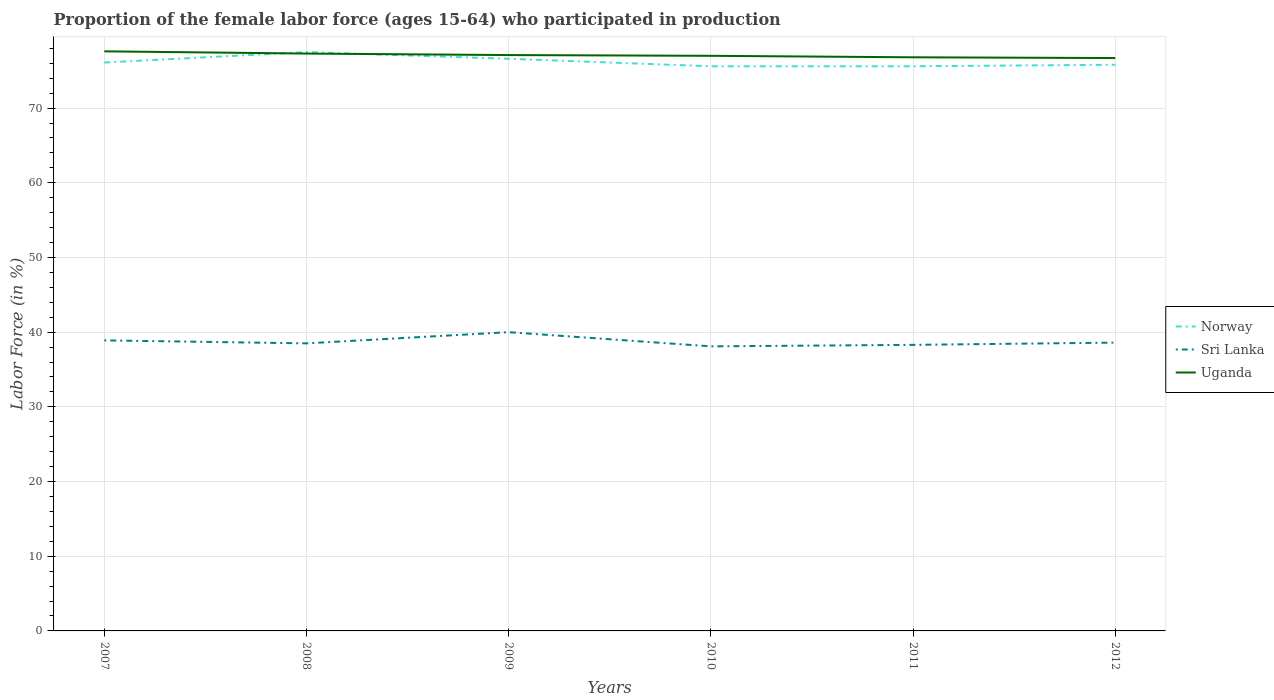Across all years, what is the maximum proportion of the female labor force who participated in production in Uganda?
Offer a terse response. 76.7. What is the total proportion of the female labor force who participated in production in Uganda in the graph?
Offer a very short reply. 0.6. What is the difference between the highest and the second highest proportion of the female labor force who participated in production in Uganda?
Offer a terse response. 0.9. Are the values on the major ticks of Y-axis written in scientific E-notation?
Your response must be concise. No. Does the graph contain grids?
Ensure brevity in your answer.  Yes. Where does the legend appear in the graph?
Your answer should be compact. Center right. How many legend labels are there?
Provide a succinct answer. 3. How are the legend labels stacked?
Provide a succinct answer. Vertical. What is the title of the graph?
Your answer should be compact. Proportion of the female labor force (ages 15-64) who participated in production. Does "Italy" appear as one of the legend labels in the graph?
Your response must be concise. No. What is the Labor Force (in %) of Norway in 2007?
Make the answer very short. 76.1. What is the Labor Force (in %) of Sri Lanka in 2007?
Offer a very short reply. 38.9. What is the Labor Force (in %) in Uganda in 2007?
Keep it short and to the point. 77.6. What is the Labor Force (in %) of Norway in 2008?
Make the answer very short. 77.5. What is the Labor Force (in %) of Sri Lanka in 2008?
Provide a short and direct response. 38.5. What is the Labor Force (in %) in Uganda in 2008?
Your response must be concise. 77.3. What is the Labor Force (in %) of Norway in 2009?
Your response must be concise. 76.6. What is the Labor Force (in %) of Uganda in 2009?
Your answer should be very brief. 77.1. What is the Labor Force (in %) in Norway in 2010?
Offer a very short reply. 75.6. What is the Labor Force (in %) of Sri Lanka in 2010?
Offer a very short reply. 38.1. What is the Labor Force (in %) in Norway in 2011?
Ensure brevity in your answer.  75.6. What is the Labor Force (in %) in Sri Lanka in 2011?
Your answer should be compact. 38.3. What is the Labor Force (in %) of Uganda in 2011?
Offer a terse response. 76.8. What is the Labor Force (in %) of Norway in 2012?
Ensure brevity in your answer.  75.8. What is the Labor Force (in %) of Sri Lanka in 2012?
Your answer should be compact. 38.6. What is the Labor Force (in %) in Uganda in 2012?
Offer a very short reply. 76.7. Across all years, what is the maximum Labor Force (in %) of Norway?
Keep it short and to the point. 77.5. Across all years, what is the maximum Labor Force (in %) in Sri Lanka?
Provide a succinct answer. 40. Across all years, what is the maximum Labor Force (in %) in Uganda?
Your answer should be compact. 77.6. Across all years, what is the minimum Labor Force (in %) of Norway?
Provide a short and direct response. 75.6. Across all years, what is the minimum Labor Force (in %) of Sri Lanka?
Offer a very short reply. 38.1. Across all years, what is the minimum Labor Force (in %) in Uganda?
Keep it short and to the point. 76.7. What is the total Labor Force (in %) of Norway in the graph?
Give a very brief answer. 457.2. What is the total Labor Force (in %) in Sri Lanka in the graph?
Keep it short and to the point. 232.4. What is the total Labor Force (in %) in Uganda in the graph?
Provide a short and direct response. 462.5. What is the difference between the Labor Force (in %) of Norway in 2007 and that in 2008?
Offer a terse response. -1.4. What is the difference between the Labor Force (in %) of Uganda in 2007 and that in 2008?
Your response must be concise. 0.3. What is the difference between the Labor Force (in %) in Norway in 2007 and that in 2010?
Keep it short and to the point. 0.5. What is the difference between the Labor Force (in %) of Norway in 2007 and that in 2011?
Your answer should be compact. 0.5. What is the difference between the Labor Force (in %) in Sri Lanka in 2007 and that in 2011?
Offer a terse response. 0.6. What is the difference between the Labor Force (in %) in Sri Lanka in 2007 and that in 2012?
Make the answer very short. 0.3. What is the difference between the Labor Force (in %) of Uganda in 2007 and that in 2012?
Offer a very short reply. 0.9. What is the difference between the Labor Force (in %) in Uganda in 2008 and that in 2009?
Offer a terse response. 0.2. What is the difference between the Labor Force (in %) in Norway in 2008 and that in 2010?
Offer a very short reply. 1.9. What is the difference between the Labor Force (in %) in Sri Lanka in 2008 and that in 2010?
Offer a terse response. 0.4. What is the difference between the Labor Force (in %) of Norway in 2008 and that in 2011?
Your answer should be very brief. 1.9. What is the difference between the Labor Force (in %) in Uganda in 2008 and that in 2011?
Provide a succinct answer. 0.5. What is the difference between the Labor Force (in %) in Norway in 2008 and that in 2012?
Offer a very short reply. 1.7. What is the difference between the Labor Force (in %) of Sri Lanka in 2009 and that in 2010?
Your response must be concise. 1.9. What is the difference between the Labor Force (in %) in Norway in 2009 and that in 2011?
Ensure brevity in your answer.  1. What is the difference between the Labor Force (in %) in Uganda in 2009 and that in 2011?
Ensure brevity in your answer.  0.3. What is the difference between the Labor Force (in %) in Uganda in 2009 and that in 2012?
Offer a very short reply. 0.4. What is the difference between the Labor Force (in %) of Uganda in 2010 and that in 2011?
Give a very brief answer. 0.2. What is the difference between the Labor Force (in %) in Norway in 2010 and that in 2012?
Your answer should be compact. -0.2. What is the difference between the Labor Force (in %) in Uganda in 2010 and that in 2012?
Offer a terse response. 0.3. What is the difference between the Labor Force (in %) in Sri Lanka in 2011 and that in 2012?
Provide a short and direct response. -0.3. What is the difference between the Labor Force (in %) in Norway in 2007 and the Labor Force (in %) in Sri Lanka in 2008?
Provide a succinct answer. 37.6. What is the difference between the Labor Force (in %) in Norway in 2007 and the Labor Force (in %) in Uganda in 2008?
Offer a very short reply. -1.2. What is the difference between the Labor Force (in %) of Sri Lanka in 2007 and the Labor Force (in %) of Uganda in 2008?
Provide a succinct answer. -38.4. What is the difference between the Labor Force (in %) of Norway in 2007 and the Labor Force (in %) of Sri Lanka in 2009?
Keep it short and to the point. 36.1. What is the difference between the Labor Force (in %) of Norway in 2007 and the Labor Force (in %) of Uganda in 2009?
Provide a short and direct response. -1. What is the difference between the Labor Force (in %) of Sri Lanka in 2007 and the Labor Force (in %) of Uganda in 2009?
Make the answer very short. -38.2. What is the difference between the Labor Force (in %) of Norway in 2007 and the Labor Force (in %) of Sri Lanka in 2010?
Give a very brief answer. 38. What is the difference between the Labor Force (in %) of Norway in 2007 and the Labor Force (in %) of Uganda in 2010?
Ensure brevity in your answer.  -0.9. What is the difference between the Labor Force (in %) in Sri Lanka in 2007 and the Labor Force (in %) in Uganda in 2010?
Ensure brevity in your answer.  -38.1. What is the difference between the Labor Force (in %) in Norway in 2007 and the Labor Force (in %) in Sri Lanka in 2011?
Provide a short and direct response. 37.8. What is the difference between the Labor Force (in %) in Sri Lanka in 2007 and the Labor Force (in %) in Uganda in 2011?
Make the answer very short. -37.9. What is the difference between the Labor Force (in %) of Norway in 2007 and the Labor Force (in %) of Sri Lanka in 2012?
Offer a very short reply. 37.5. What is the difference between the Labor Force (in %) of Norway in 2007 and the Labor Force (in %) of Uganda in 2012?
Your answer should be very brief. -0.6. What is the difference between the Labor Force (in %) of Sri Lanka in 2007 and the Labor Force (in %) of Uganda in 2012?
Your answer should be very brief. -37.8. What is the difference between the Labor Force (in %) of Norway in 2008 and the Labor Force (in %) of Sri Lanka in 2009?
Ensure brevity in your answer.  37.5. What is the difference between the Labor Force (in %) in Sri Lanka in 2008 and the Labor Force (in %) in Uganda in 2009?
Keep it short and to the point. -38.6. What is the difference between the Labor Force (in %) of Norway in 2008 and the Labor Force (in %) of Sri Lanka in 2010?
Give a very brief answer. 39.4. What is the difference between the Labor Force (in %) of Sri Lanka in 2008 and the Labor Force (in %) of Uganda in 2010?
Your answer should be very brief. -38.5. What is the difference between the Labor Force (in %) of Norway in 2008 and the Labor Force (in %) of Sri Lanka in 2011?
Offer a terse response. 39.2. What is the difference between the Labor Force (in %) of Norway in 2008 and the Labor Force (in %) of Uganda in 2011?
Your answer should be compact. 0.7. What is the difference between the Labor Force (in %) of Sri Lanka in 2008 and the Labor Force (in %) of Uganda in 2011?
Your answer should be compact. -38.3. What is the difference between the Labor Force (in %) of Norway in 2008 and the Labor Force (in %) of Sri Lanka in 2012?
Your answer should be compact. 38.9. What is the difference between the Labor Force (in %) in Sri Lanka in 2008 and the Labor Force (in %) in Uganda in 2012?
Provide a short and direct response. -38.2. What is the difference between the Labor Force (in %) in Norway in 2009 and the Labor Force (in %) in Sri Lanka in 2010?
Offer a terse response. 38.5. What is the difference between the Labor Force (in %) of Sri Lanka in 2009 and the Labor Force (in %) of Uganda in 2010?
Provide a short and direct response. -37. What is the difference between the Labor Force (in %) in Norway in 2009 and the Labor Force (in %) in Sri Lanka in 2011?
Keep it short and to the point. 38.3. What is the difference between the Labor Force (in %) in Sri Lanka in 2009 and the Labor Force (in %) in Uganda in 2011?
Ensure brevity in your answer.  -36.8. What is the difference between the Labor Force (in %) of Norway in 2009 and the Labor Force (in %) of Sri Lanka in 2012?
Offer a terse response. 38. What is the difference between the Labor Force (in %) in Norway in 2009 and the Labor Force (in %) in Uganda in 2012?
Offer a terse response. -0.1. What is the difference between the Labor Force (in %) in Sri Lanka in 2009 and the Labor Force (in %) in Uganda in 2012?
Give a very brief answer. -36.7. What is the difference between the Labor Force (in %) of Norway in 2010 and the Labor Force (in %) of Sri Lanka in 2011?
Your answer should be very brief. 37.3. What is the difference between the Labor Force (in %) in Norway in 2010 and the Labor Force (in %) in Uganda in 2011?
Offer a terse response. -1.2. What is the difference between the Labor Force (in %) in Sri Lanka in 2010 and the Labor Force (in %) in Uganda in 2011?
Your response must be concise. -38.7. What is the difference between the Labor Force (in %) of Norway in 2010 and the Labor Force (in %) of Uganda in 2012?
Ensure brevity in your answer.  -1.1. What is the difference between the Labor Force (in %) of Sri Lanka in 2010 and the Labor Force (in %) of Uganda in 2012?
Give a very brief answer. -38.6. What is the difference between the Labor Force (in %) in Sri Lanka in 2011 and the Labor Force (in %) in Uganda in 2012?
Offer a very short reply. -38.4. What is the average Labor Force (in %) of Norway per year?
Provide a succinct answer. 76.2. What is the average Labor Force (in %) of Sri Lanka per year?
Offer a very short reply. 38.73. What is the average Labor Force (in %) of Uganda per year?
Keep it short and to the point. 77.08. In the year 2007, what is the difference between the Labor Force (in %) in Norway and Labor Force (in %) in Sri Lanka?
Ensure brevity in your answer.  37.2. In the year 2007, what is the difference between the Labor Force (in %) of Norway and Labor Force (in %) of Uganda?
Give a very brief answer. -1.5. In the year 2007, what is the difference between the Labor Force (in %) of Sri Lanka and Labor Force (in %) of Uganda?
Provide a succinct answer. -38.7. In the year 2008, what is the difference between the Labor Force (in %) of Norway and Labor Force (in %) of Sri Lanka?
Your response must be concise. 39. In the year 2008, what is the difference between the Labor Force (in %) in Sri Lanka and Labor Force (in %) in Uganda?
Provide a succinct answer. -38.8. In the year 2009, what is the difference between the Labor Force (in %) of Norway and Labor Force (in %) of Sri Lanka?
Provide a succinct answer. 36.6. In the year 2009, what is the difference between the Labor Force (in %) in Norway and Labor Force (in %) in Uganda?
Your answer should be very brief. -0.5. In the year 2009, what is the difference between the Labor Force (in %) of Sri Lanka and Labor Force (in %) of Uganda?
Ensure brevity in your answer.  -37.1. In the year 2010, what is the difference between the Labor Force (in %) in Norway and Labor Force (in %) in Sri Lanka?
Provide a succinct answer. 37.5. In the year 2010, what is the difference between the Labor Force (in %) of Sri Lanka and Labor Force (in %) of Uganda?
Give a very brief answer. -38.9. In the year 2011, what is the difference between the Labor Force (in %) in Norway and Labor Force (in %) in Sri Lanka?
Ensure brevity in your answer.  37.3. In the year 2011, what is the difference between the Labor Force (in %) in Sri Lanka and Labor Force (in %) in Uganda?
Offer a terse response. -38.5. In the year 2012, what is the difference between the Labor Force (in %) of Norway and Labor Force (in %) of Sri Lanka?
Your answer should be very brief. 37.2. In the year 2012, what is the difference between the Labor Force (in %) of Sri Lanka and Labor Force (in %) of Uganda?
Provide a succinct answer. -38.1. What is the ratio of the Labor Force (in %) in Norway in 2007 to that in 2008?
Provide a succinct answer. 0.98. What is the ratio of the Labor Force (in %) in Sri Lanka in 2007 to that in 2008?
Keep it short and to the point. 1.01. What is the ratio of the Labor Force (in %) in Sri Lanka in 2007 to that in 2009?
Provide a short and direct response. 0.97. What is the ratio of the Labor Force (in %) in Uganda in 2007 to that in 2009?
Provide a succinct answer. 1.01. What is the ratio of the Labor Force (in %) in Norway in 2007 to that in 2010?
Offer a very short reply. 1.01. What is the ratio of the Labor Force (in %) in Uganda in 2007 to that in 2010?
Your answer should be very brief. 1.01. What is the ratio of the Labor Force (in %) in Norway in 2007 to that in 2011?
Give a very brief answer. 1.01. What is the ratio of the Labor Force (in %) in Sri Lanka in 2007 to that in 2011?
Ensure brevity in your answer.  1.02. What is the ratio of the Labor Force (in %) of Uganda in 2007 to that in 2011?
Offer a terse response. 1.01. What is the ratio of the Labor Force (in %) in Sri Lanka in 2007 to that in 2012?
Your answer should be very brief. 1.01. What is the ratio of the Labor Force (in %) in Uganda in 2007 to that in 2012?
Your response must be concise. 1.01. What is the ratio of the Labor Force (in %) of Norway in 2008 to that in 2009?
Ensure brevity in your answer.  1.01. What is the ratio of the Labor Force (in %) of Sri Lanka in 2008 to that in 2009?
Keep it short and to the point. 0.96. What is the ratio of the Labor Force (in %) in Norway in 2008 to that in 2010?
Make the answer very short. 1.03. What is the ratio of the Labor Force (in %) in Sri Lanka in 2008 to that in 2010?
Your answer should be very brief. 1.01. What is the ratio of the Labor Force (in %) in Uganda in 2008 to that in 2010?
Make the answer very short. 1. What is the ratio of the Labor Force (in %) in Norway in 2008 to that in 2011?
Make the answer very short. 1.03. What is the ratio of the Labor Force (in %) of Norway in 2008 to that in 2012?
Your answer should be compact. 1.02. What is the ratio of the Labor Force (in %) of Sri Lanka in 2008 to that in 2012?
Your answer should be compact. 1. What is the ratio of the Labor Force (in %) in Norway in 2009 to that in 2010?
Offer a very short reply. 1.01. What is the ratio of the Labor Force (in %) of Sri Lanka in 2009 to that in 2010?
Ensure brevity in your answer.  1.05. What is the ratio of the Labor Force (in %) of Uganda in 2009 to that in 2010?
Offer a terse response. 1. What is the ratio of the Labor Force (in %) in Norway in 2009 to that in 2011?
Provide a short and direct response. 1.01. What is the ratio of the Labor Force (in %) of Sri Lanka in 2009 to that in 2011?
Provide a succinct answer. 1.04. What is the ratio of the Labor Force (in %) of Norway in 2009 to that in 2012?
Your answer should be very brief. 1.01. What is the ratio of the Labor Force (in %) of Sri Lanka in 2009 to that in 2012?
Make the answer very short. 1.04. What is the ratio of the Labor Force (in %) in Norway in 2010 to that in 2011?
Keep it short and to the point. 1. What is the ratio of the Labor Force (in %) in Sri Lanka in 2010 to that in 2012?
Your response must be concise. 0.99. What is the ratio of the Labor Force (in %) of Uganda in 2010 to that in 2012?
Offer a very short reply. 1. What is the ratio of the Labor Force (in %) in Norway in 2011 to that in 2012?
Offer a terse response. 1. What is the ratio of the Labor Force (in %) in Sri Lanka in 2011 to that in 2012?
Ensure brevity in your answer.  0.99. What is the difference between the highest and the second highest Labor Force (in %) of Norway?
Make the answer very short. 0.9. What is the difference between the highest and the second highest Labor Force (in %) in Sri Lanka?
Your answer should be very brief. 1.1. What is the difference between the highest and the second highest Labor Force (in %) of Uganda?
Offer a terse response. 0.3. 